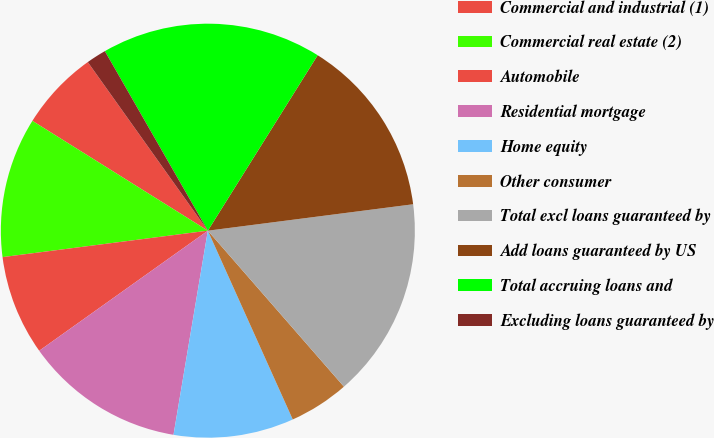<chart> <loc_0><loc_0><loc_500><loc_500><pie_chart><fcel>Commercial and industrial (1)<fcel>Commercial real estate (2)<fcel>Automobile<fcel>Residential mortgage<fcel>Home equity<fcel>Other consumer<fcel>Total excl loans guaranteed by<fcel>Add loans guaranteed by US<fcel>Total accruing loans and<fcel>Excluding loans guaranteed by<nl><fcel>6.25%<fcel>10.94%<fcel>7.81%<fcel>12.5%<fcel>9.38%<fcel>4.69%<fcel>15.62%<fcel>14.06%<fcel>17.19%<fcel>1.56%<nl></chart> 